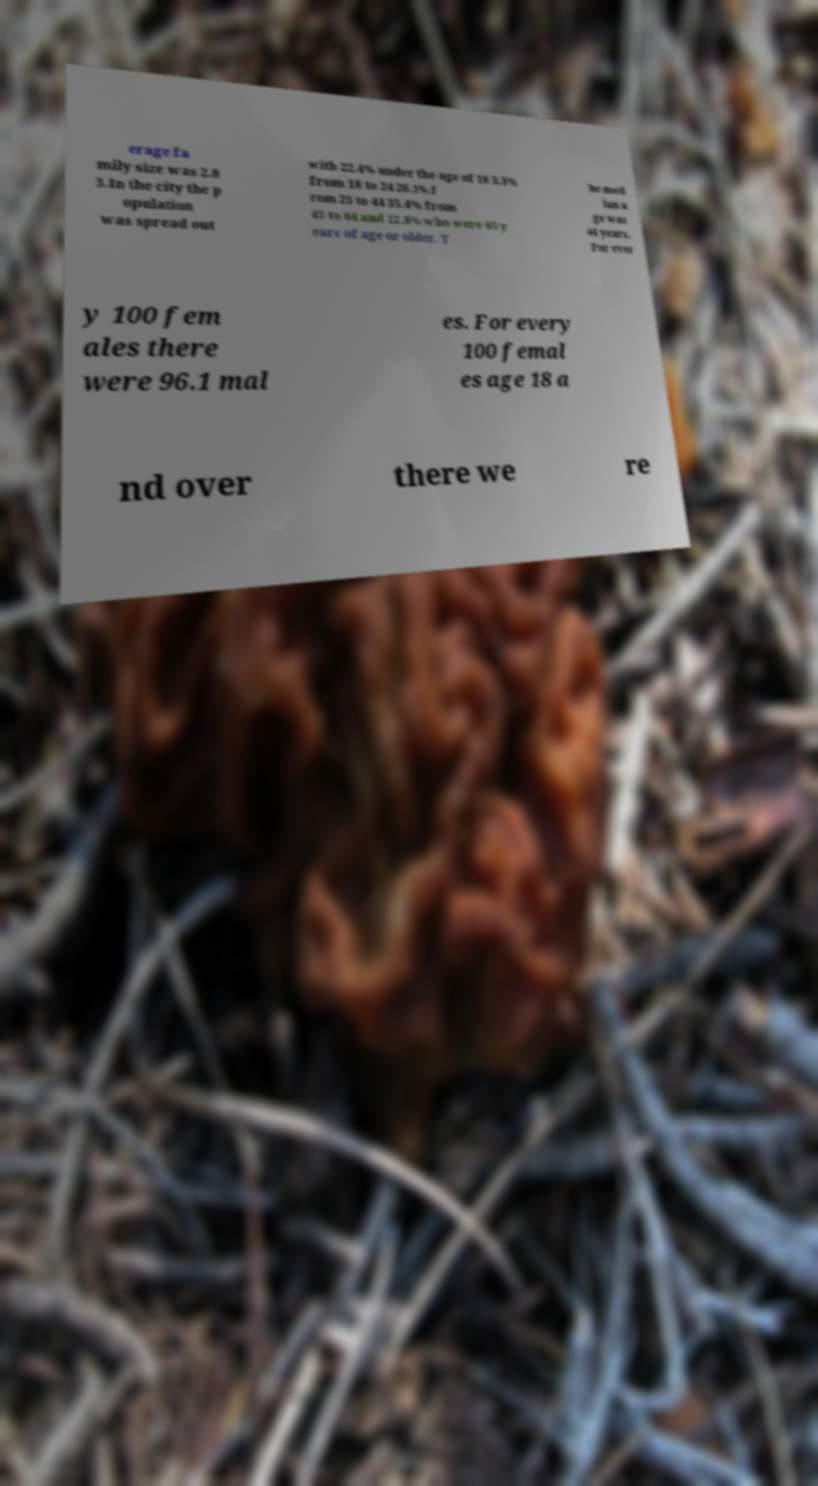Please read and relay the text visible in this image. What does it say? erage fa mily size was 2.8 3.In the city the p opulation was spread out with 22.4% under the age of 18 3.3% from 18 to 24 26.1% f rom 25 to 44 35.4% from 45 to 64 and 12.8% who were 65 y ears of age or older. T he med ian a ge was 44 years. For ever y 100 fem ales there were 96.1 mal es. For every 100 femal es age 18 a nd over there we re 